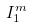<formula> <loc_0><loc_0><loc_500><loc_500>I _ { 1 } ^ { m }</formula> 